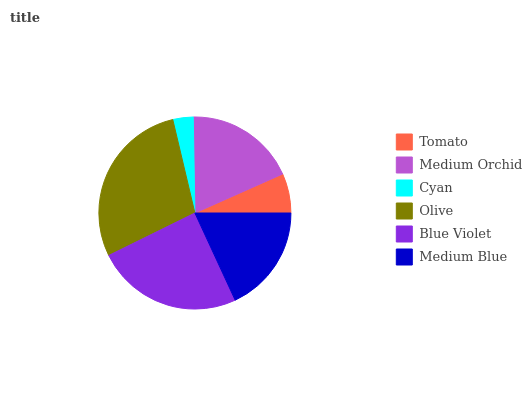Is Cyan the minimum?
Answer yes or no. Yes. Is Olive the maximum?
Answer yes or no. Yes. Is Medium Orchid the minimum?
Answer yes or no. No. Is Medium Orchid the maximum?
Answer yes or no. No. Is Medium Orchid greater than Tomato?
Answer yes or no. Yes. Is Tomato less than Medium Orchid?
Answer yes or no. Yes. Is Tomato greater than Medium Orchid?
Answer yes or no. No. Is Medium Orchid less than Tomato?
Answer yes or no. No. Is Medium Orchid the high median?
Answer yes or no. Yes. Is Medium Blue the low median?
Answer yes or no. Yes. Is Blue Violet the high median?
Answer yes or no. No. Is Medium Orchid the low median?
Answer yes or no. No. 